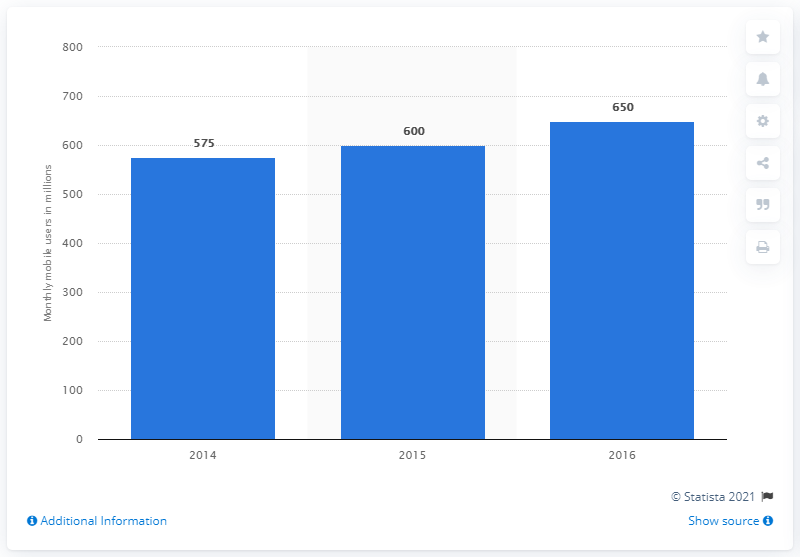Draw attention to some important aspects in this diagram. As of December 31, 2016, Yahoo had approximately 650 million mobile users. 